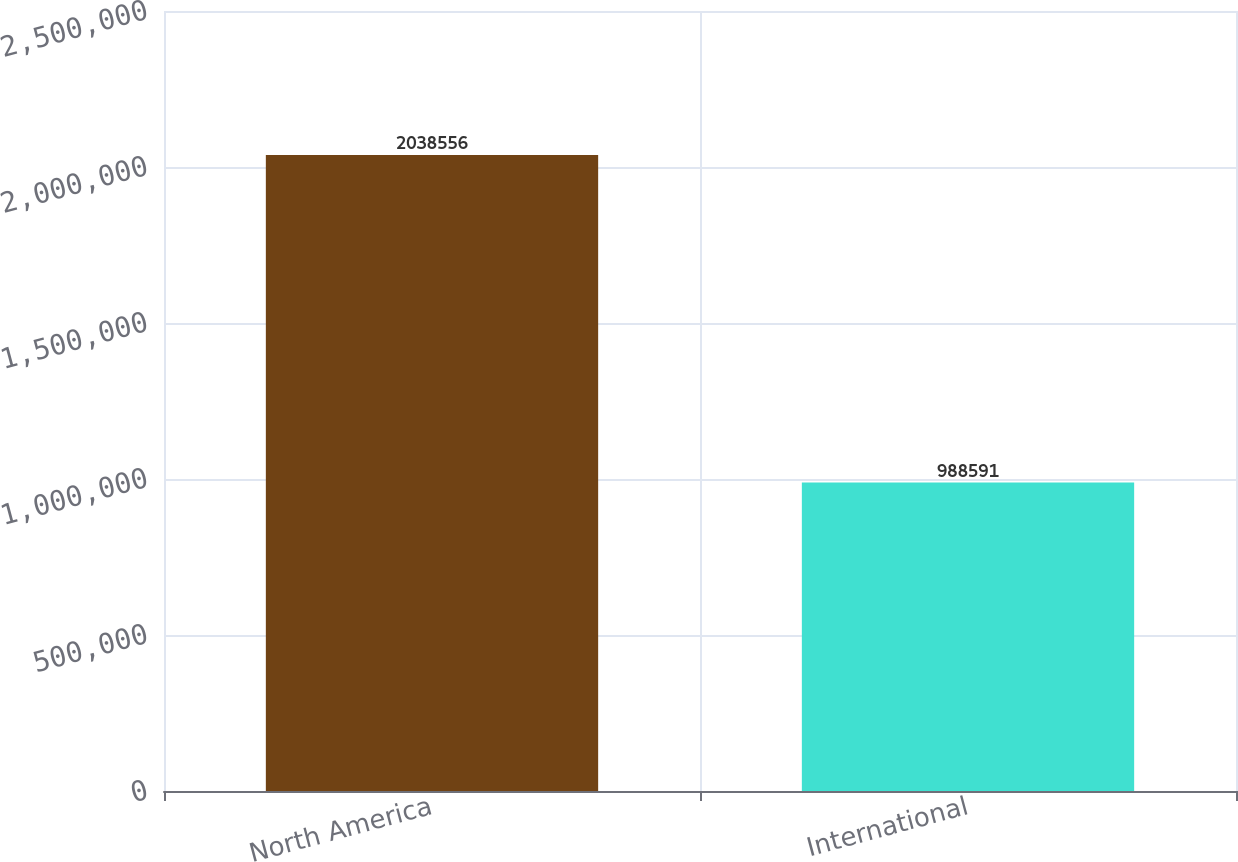Convert chart. <chart><loc_0><loc_0><loc_500><loc_500><bar_chart><fcel>North America<fcel>International<nl><fcel>2.03856e+06<fcel>988591<nl></chart> 